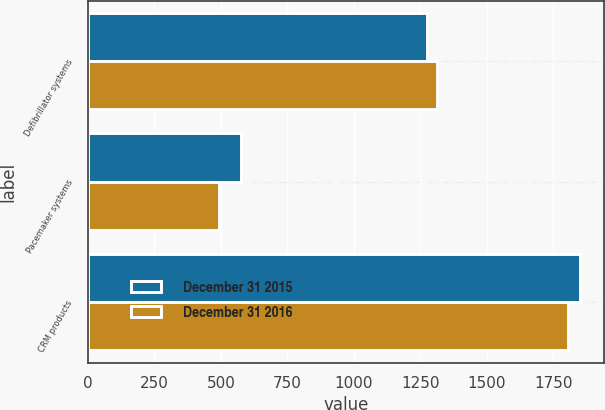Convert chart. <chart><loc_0><loc_0><loc_500><loc_500><stacked_bar_chart><ecel><fcel>Defibrillator systems<fcel>Pacemaker systems<fcel>CRM products<nl><fcel>December 31 2015<fcel>1274<fcel>576<fcel>1850<nl><fcel>December 31 2016<fcel>1313<fcel>494<fcel>1807<nl></chart> 